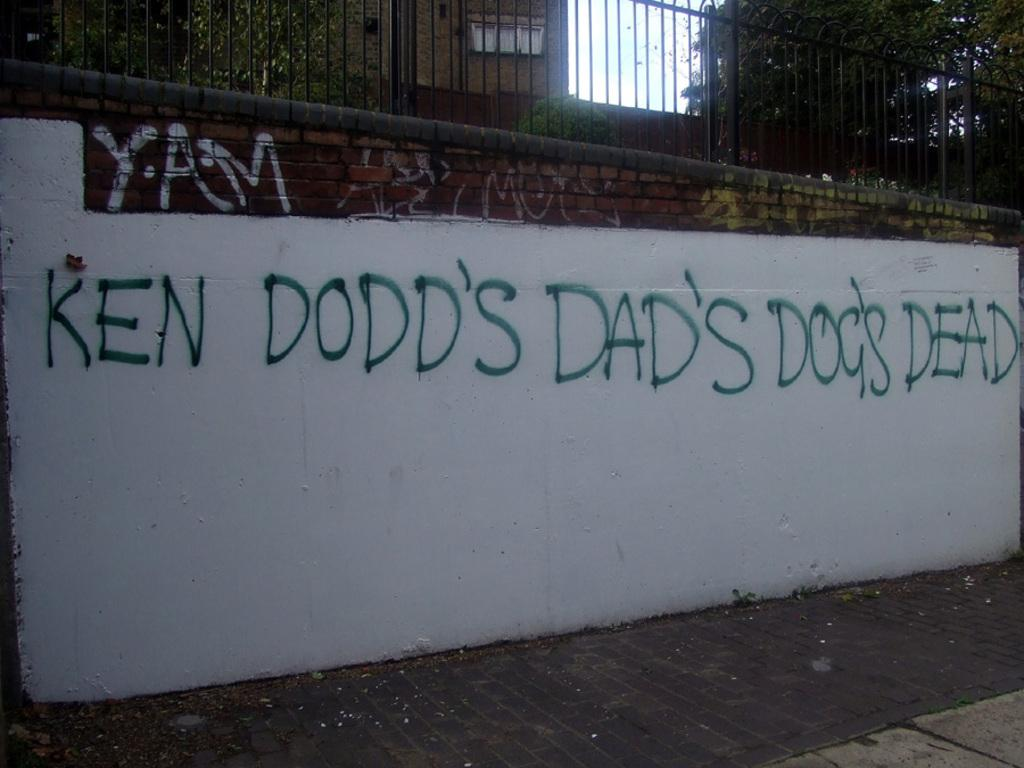What is written on in the image? There is text written on a brick wall in the image. What type of fence is above the wall? There is a metal rod fence above the wall. What can be seen behind the fence? Trees and buildings are visible behind the fence. What type of horn can be heard coming from the pig in the image? There is no pig or horn present in the image. What is the condition of the pig in the image? There is no pig present in the image, so its condition cannot be determined. 